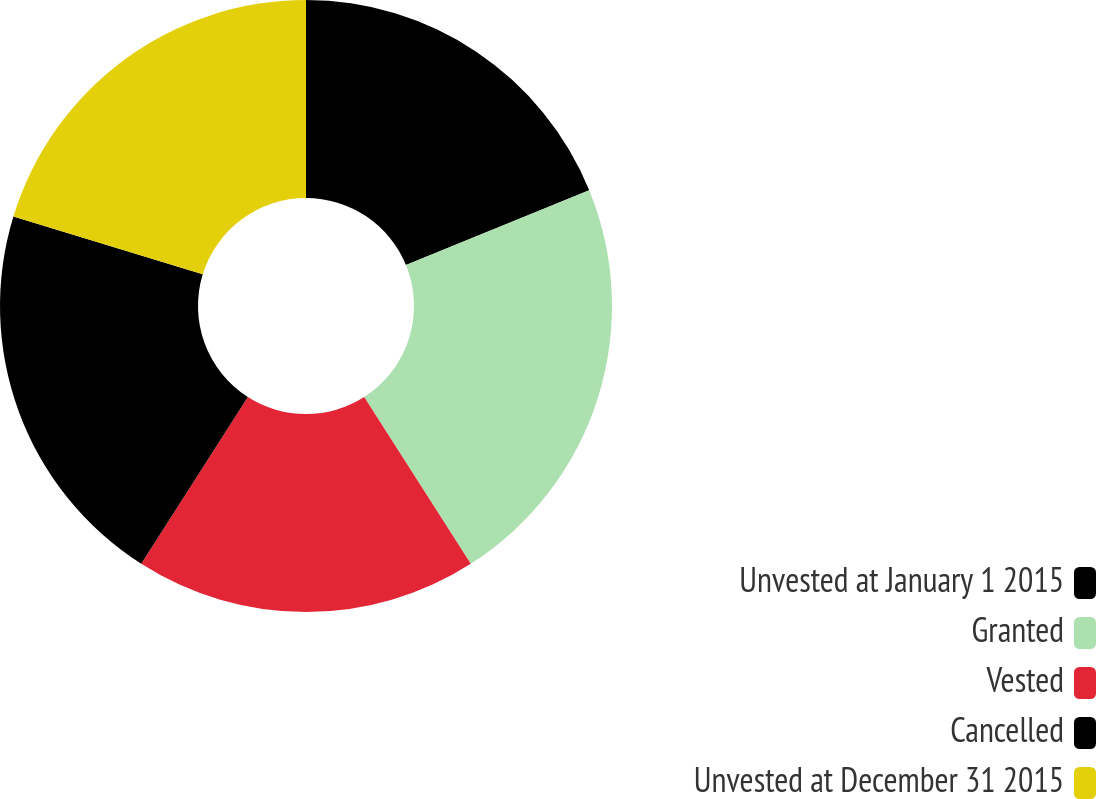<chart> <loc_0><loc_0><loc_500><loc_500><pie_chart><fcel>Unvested at January 1 2015<fcel>Granted<fcel>Vested<fcel>Cancelled<fcel>Unvested at December 31 2015<nl><fcel>18.82%<fcel>22.13%<fcel>18.1%<fcel>20.68%<fcel>20.27%<nl></chart> 